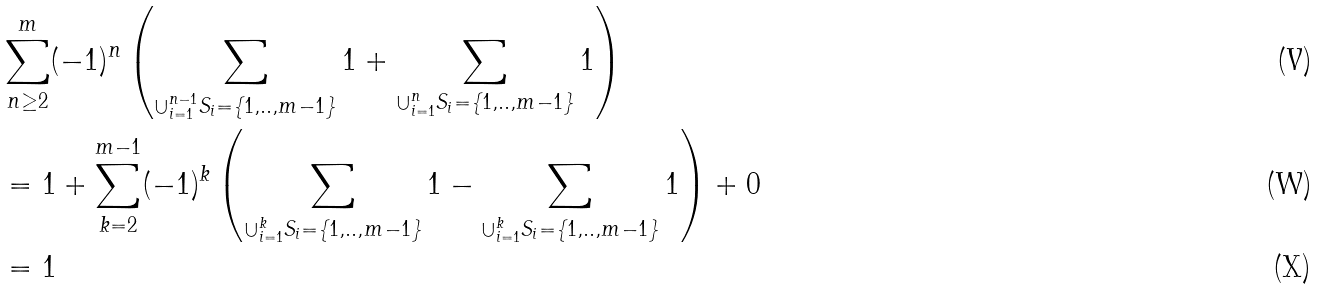Convert formula to latex. <formula><loc_0><loc_0><loc_500><loc_500>& \sum _ { n \geq 2 } ^ { m } ( - 1 ) ^ { n } \left ( \sum _ { \cup _ { i = 1 } ^ { n - 1 } S _ { i } = \{ 1 , . . , m - 1 \} } 1 + \sum _ { \cup _ { i = 1 } ^ { n } S _ { i } = \{ 1 , . . , m - 1 \} } 1 \right ) \\ & = 1 + \sum _ { k = 2 } ^ { m - 1 } ( - 1 ) ^ { k } \left ( \sum _ { \cup _ { i = 1 } ^ { k } S _ { i } = \{ 1 , . . , m - 1 \} } 1 - \sum _ { \cup _ { i = 1 } ^ { k } S _ { i } = \{ 1 , . . , m - 1 \} } 1 \right ) + 0 \\ & = 1</formula> 